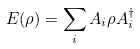<formula> <loc_0><loc_0><loc_500><loc_500>E ( \rho ) = \sum _ { i } A _ { i } \rho A _ { i } ^ { \dagger }</formula> 